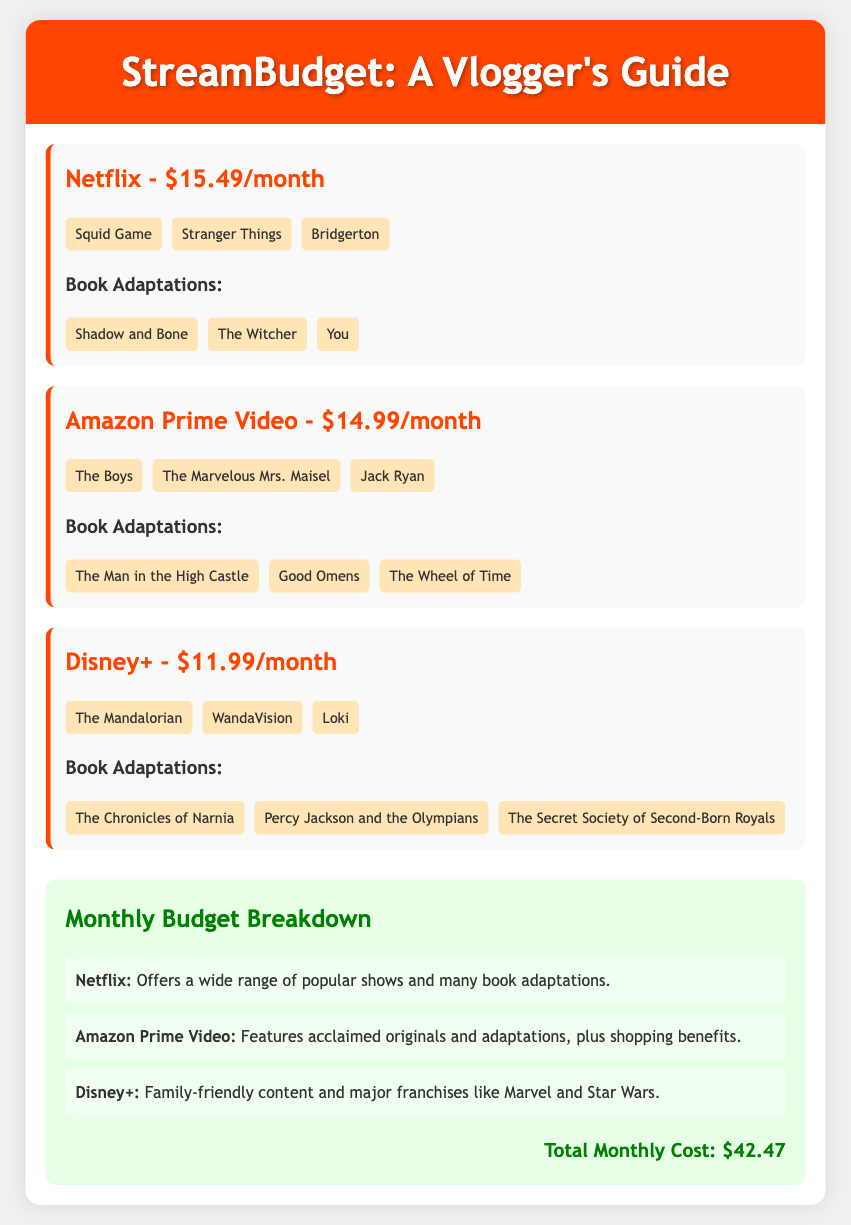What is the monthly cost of Netflix? The document states that Netflix costs $15.49 per month.
Answer: $15.49 How many platforms are listed in the document? The document lists three streaming platforms: Netflix, Amazon Prime Video, and Disney+.
Answer: 3 Which platform features "The Boys"? "The Boys" is listed under Amazon Prime Video in the document.
Answer: Amazon Prime Video What is the total monthly cost for all platforms? The total monthly cost is provided as the sum of the costs of all three platforms, which is $42.47.
Answer: $42.47 Name one book adaptation available on Disney+. The document states that "The Chronicles of Narnia" is a book adaptation available on Disney+.
Answer: The Chronicles of Narnia Which platform has the least monthly subscription cost? The document indicates that Disney+ has the lowest subscription cost at $11.99 per month.
Answer: Disney+ What is a popular show mentioned for Amazon Prime Video? The document lists "The Marvelous Mrs. Maisel" as a popular show on Amazon Prime Video.
Answer: The Marvelous Mrs. Maisel Which platform is recommended for family-friendly content? The document recommends Disney+ for its family-friendly content.
Answer: Disney+ What adaptations does Netflix offer? The document lists "Shadow and Bone," "The Witcher," and "You" as adaptations offered by Netflix.
Answer: Shadow and Bone, The Witcher, You 